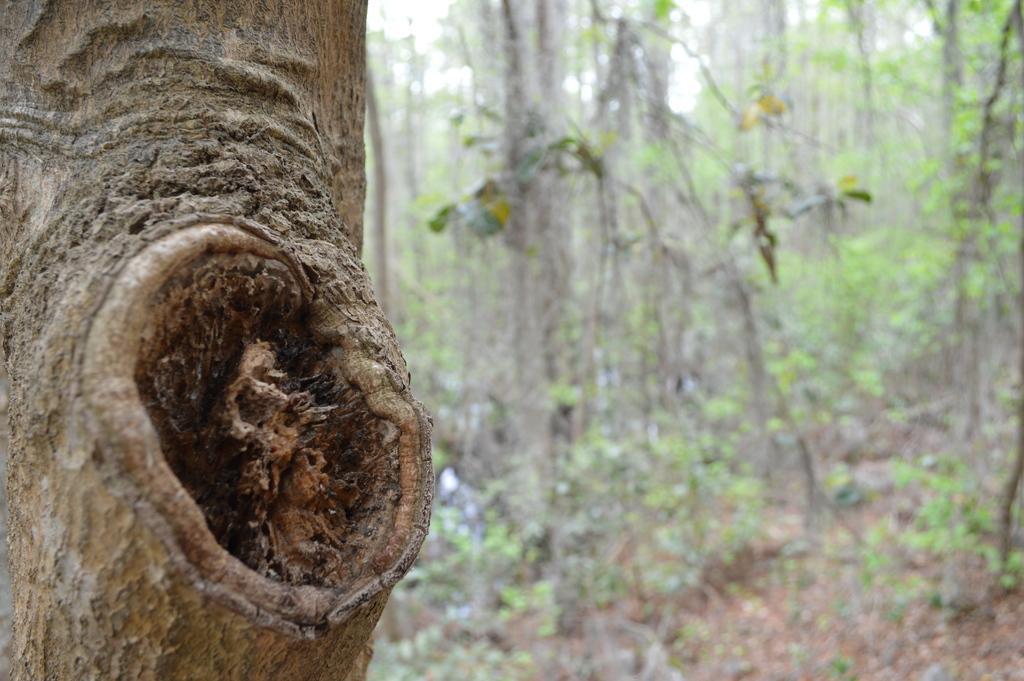In one or two sentences, can you explain what this image depicts? In this image we can see many trees. There is a trunk of the tree at the right side of the image. 